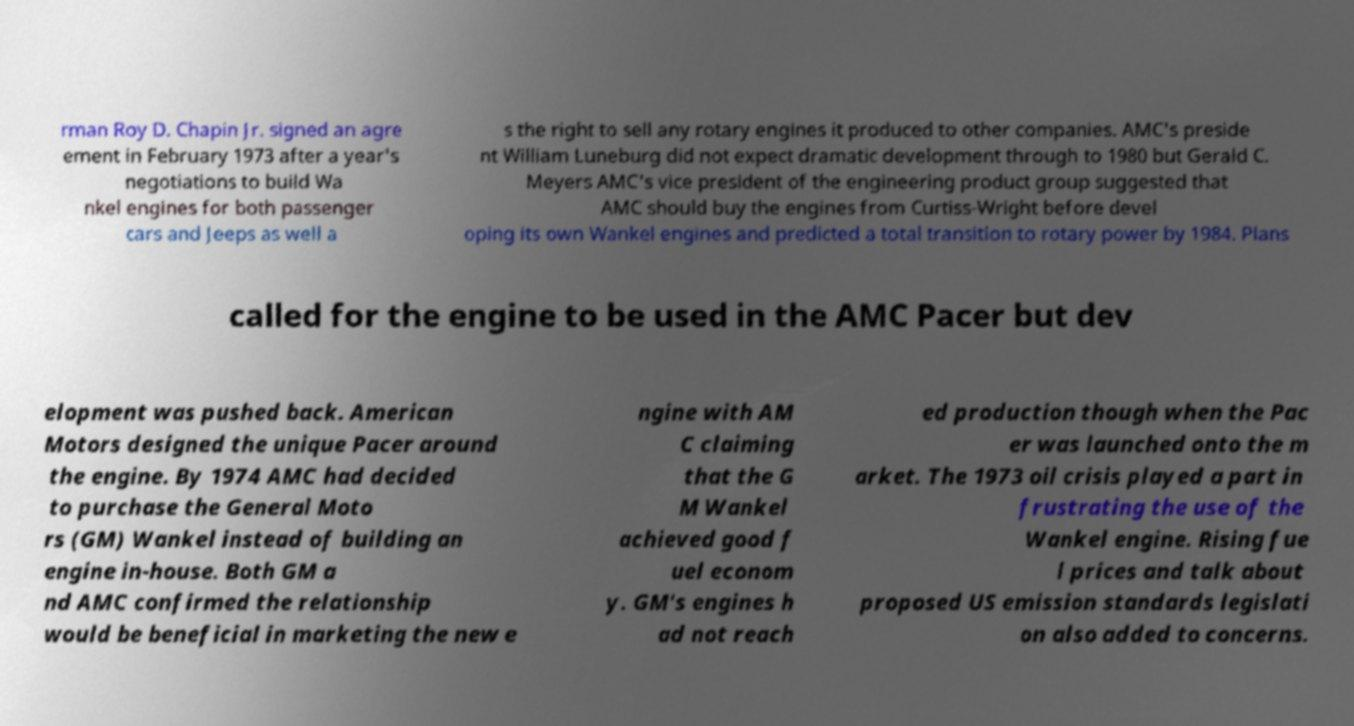Please read and relay the text visible in this image. What does it say? rman Roy D. Chapin Jr. signed an agre ement in February 1973 after a year's negotiations to build Wa nkel engines for both passenger cars and Jeeps as well a s the right to sell any rotary engines it produced to other companies. AMC's preside nt William Luneburg did not expect dramatic development through to 1980 but Gerald C. Meyers AMC's vice president of the engineering product group suggested that AMC should buy the engines from Curtiss-Wright before devel oping its own Wankel engines and predicted a total transition to rotary power by 1984. Plans called for the engine to be used in the AMC Pacer but dev elopment was pushed back. American Motors designed the unique Pacer around the engine. By 1974 AMC had decided to purchase the General Moto rs (GM) Wankel instead of building an engine in-house. Both GM a nd AMC confirmed the relationship would be beneficial in marketing the new e ngine with AM C claiming that the G M Wankel achieved good f uel econom y. GM's engines h ad not reach ed production though when the Pac er was launched onto the m arket. The 1973 oil crisis played a part in frustrating the use of the Wankel engine. Rising fue l prices and talk about proposed US emission standards legislati on also added to concerns. 